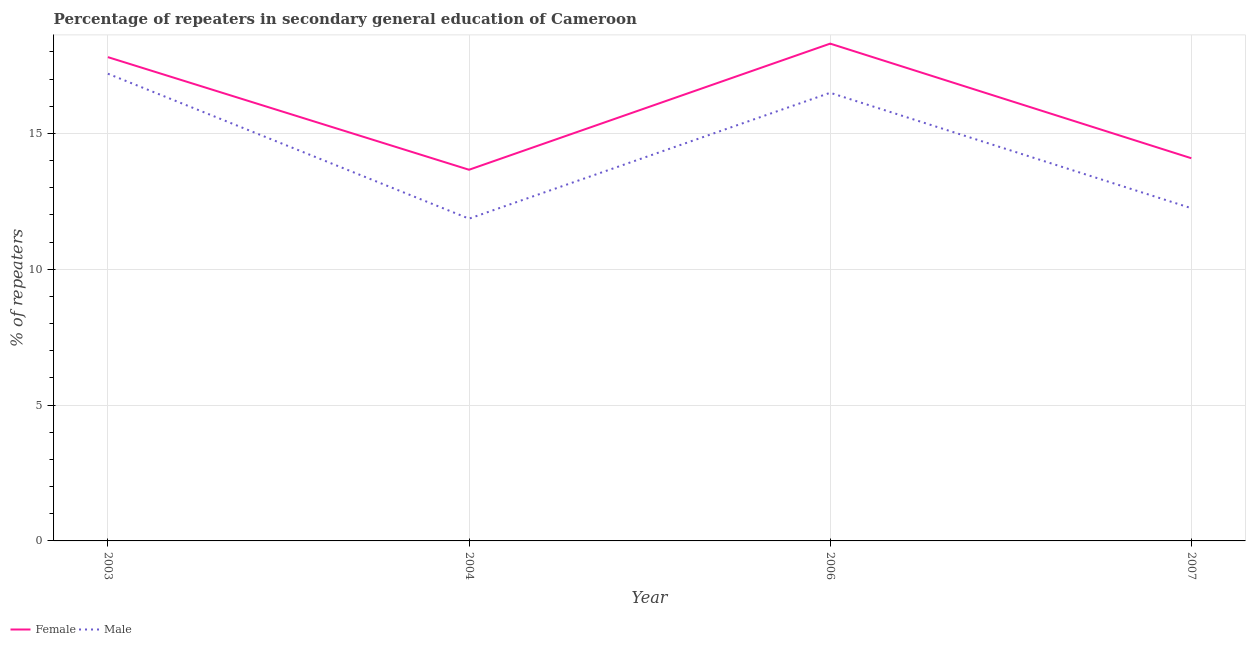How many different coloured lines are there?
Ensure brevity in your answer.  2. Does the line corresponding to percentage of female repeaters intersect with the line corresponding to percentage of male repeaters?
Offer a very short reply. No. What is the percentage of female repeaters in 2007?
Make the answer very short. 14.09. Across all years, what is the maximum percentage of male repeaters?
Keep it short and to the point. 17.2. Across all years, what is the minimum percentage of male repeaters?
Provide a succinct answer. 11.86. What is the total percentage of male repeaters in the graph?
Give a very brief answer. 57.81. What is the difference between the percentage of male repeaters in 2003 and that in 2006?
Ensure brevity in your answer.  0.7. What is the difference between the percentage of male repeaters in 2006 and the percentage of female repeaters in 2003?
Offer a terse response. -1.31. What is the average percentage of female repeaters per year?
Your answer should be compact. 15.97. In the year 2006, what is the difference between the percentage of female repeaters and percentage of male repeaters?
Provide a short and direct response. 1.81. In how many years, is the percentage of male repeaters greater than 15 %?
Your answer should be very brief. 2. What is the ratio of the percentage of male repeaters in 2004 to that in 2007?
Your response must be concise. 0.97. What is the difference between the highest and the second highest percentage of male repeaters?
Offer a terse response. 0.7. What is the difference between the highest and the lowest percentage of male repeaters?
Your response must be concise. 5.34. Does the percentage of female repeaters monotonically increase over the years?
Provide a succinct answer. No. Is the percentage of male repeaters strictly greater than the percentage of female repeaters over the years?
Keep it short and to the point. No. What is the difference between two consecutive major ticks on the Y-axis?
Make the answer very short. 5. Does the graph contain any zero values?
Provide a short and direct response. No. Does the graph contain grids?
Your answer should be very brief. Yes. How many legend labels are there?
Give a very brief answer. 2. How are the legend labels stacked?
Provide a short and direct response. Horizontal. What is the title of the graph?
Your answer should be very brief. Percentage of repeaters in secondary general education of Cameroon. What is the label or title of the Y-axis?
Your answer should be very brief. % of repeaters. What is the % of repeaters in Female in 2003?
Offer a very short reply. 17.81. What is the % of repeaters of Male in 2003?
Offer a terse response. 17.2. What is the % of repeaters in Female in 2004?
Keep it short and to the point. 13.66. What is the % of repeaters in Male in 2004?
Give a very brief answer. 11.86. What is the % of repeaters of Female in 2006?
Provide a short and direct response. 18.31. What is the % of repeaters in Male in 2006?
Your answer should be compact. 16.5. What is the % of repeaters in Female in 2007?
Provide a short and direct response. 14.09. What is the % of repeaters in Male in 2007?
Make the answer very short. 12.25. Across all years, what is the maximum % of repeaters of Female?
Provide a short and direct response. 18.31. Across all years, what is the maximum % of repeaters of Male?
Provide a short and direct response. 17.2. Across all years, what is the minimum % of repeaters of Female?
Your answer should be very brief. 13.66. Across all years, what is the minimum % of repeaters of Male?
Provide a succinct answer. 11.86. What is the total % of repeaters in Female in the graph?
Provide a succinct answer. 63.87. What is the total % of repeaters of Male in the graph?
Your answer should be compact. 57.81. What is the difference between the % of repeaters in Female in 2003 and that in 2004?
Provide a short and direct response. 4.15. What is the difference between the % of repeaters in Male in 2003 and that in 2004?
Offer a very short reply. 5.34. What is the difference between the % of repeaters in Female in 2003 and that in 2006?
Offer a very short reply. -0.5. What is the difference between the % of repeaters in Male in 2003 and that in 2006?
Keep it short and to the point. 0.7. What is the difference between the % of repeaters in Female in 2003 and that in 2007?
Your answer should be compact. 3.72. What is the difference between the % of repeaters of Male in 2003 and that in 2007?
Keep it short and to the point. 4.95. What is the difference between the % of repeaters of Female in 2004 and that in 2006?
Your answer should be compact. -4.64. What is the difference between the % of repeaters in Male in 2004 and that in 2006?
Your response must be concise. -4.63. What is the difference between the % of repeaters of Female in 2004 and that in 2007?
Ensure brevity in your answer.  -0.42. What is the difference between the % of repeaters in Male in 2004 and that in 2007?
Provide a succinct answer. -0.39. What is the difference between the % of repeaters of Female in 2006 and that in 2007?
Offer a terse response. 4.22. What is the difference between the % of repeaters in Male in 2006 and that in 2007?
Offer a very short reply. 4.25. What is the difference between the % of repeaters in Female in 2003 and the % of repeaters in Male in 2004?
Provide a succinct answer. 5.95. What is the difference between the % of repeaters in Female in 2003 and the % of repeaters in Male in 2006?
Ensure brevity in your answer.  1.31. What is the difference between the % of repeaters of Female in 2003 and the % of repeaters of Male in 2007?
Offer a very short reply. 5.56. What is the difference between the % of repeaters in Female in 2004 and the % of repeaters in Male in 2006?
Offer a very short reply. -2.83. What is the difference between the % of repeaters in Female in 2004 and the % of repeaters in Male in 2007?
Keep it short and to the point. 1.42. What is the difference between the % of repeaters of Female in 2006 and the % of repeaters of Male in 2007?
Make the answer very short. 6.06. What is the average % of repeaters of Female per year?
Your answer should be very brief. 15.97. What is the average % of repeaters in Male per year?
Your response must be concise. 14.45. In the year 2003, what is the difference between the % of repeaters in Female and % of repeaters in Male?
Your answer should be very brief. 0.61. In the year 2004, what is the difference between the % of repeaters of Female and % of repeaters of Male?
Provide a succinct answer. 1.8. In the year 2006, what is the difference between the % of repeaters of Female and % of repeaters of Male?
Give a very brief answer. 1.81. In the year 2007, what is the difference between the % of repeaters of Female and % of repeaters of Male?
Make the answer very short. 1.84. What is the ratio of the % of repeaters of Female in 2003 to that in 2004?
Offer a terse response. 1.3. What is the ratio of the % of repeaters of Male in 2003 to that in 2004?
Your answer should be compact. 1.45. What is the ratio of the % of repeaters of Female in 2003 to that in 2006?
Your answer should be compact. 0.97. What is the ratio of the % of repeaters in Male in 2003 to that in 2006?
Provide a succinct answer. 1.04. What is the ratio of the % of repeaters of Female in 2003 to that in 2007?
Make the answer very short. 1.26. What is the ratio of the % of repeaters of Male in 2003 to that in 2007?
Offer a very short reply. 1.4. What is the ratio of the % of repeaters of Female in 2004 to that in 2006?
Ensure brevity in your answer.  0.75. What is the ratio of the % of repeaters of Male in 2004 to that in 2006?
Keep it short and to the point. 0.72. What is the ratio of the % of repeaters of Female in 2004 to that in 2007?
Provide a succinct answer. 0.97. What is the ratio of the % of repeaters in Male in 2004 to that in 2007?
Provide a short and direct response. 0.97. What is the ratio of the % of repeaters of Female in 2006 to that in 2007?
Offer a very short reply. 1.3. What is the ratio of the % of repeaters of Male in 2006 to that in 2007?
Keep it short and to the point. 1.35. What is the difference between the highest and the second highest % of repeaters in Female?
Keep it short and to the point. 0.5. What is the difference between the highest and the second highest % of repeaters of Male?
Offer a very short reply. 0.7. What is the difference between the highest and the lowest % of repeaters of Female?
Make the answer very short. 4.64. What is the difference between the highest and the lowest % of repeaters in Male?
Your response must be concise. 5.34. 